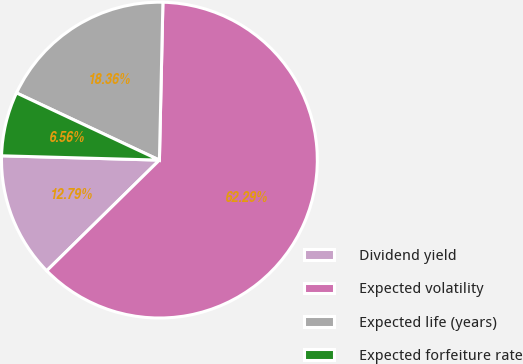<chart> <loc_0><loc_0><loc_500><loc_500><pie_chart><fcel>Dividend yield<fcel>Expected volatility<fcel>Expected life (years)<fcel>Expected forfeiture rate<nl><fcel>12.79%<fcel>62.3%<fcel>18.36%<fcel>6.56%<nl></chart> 